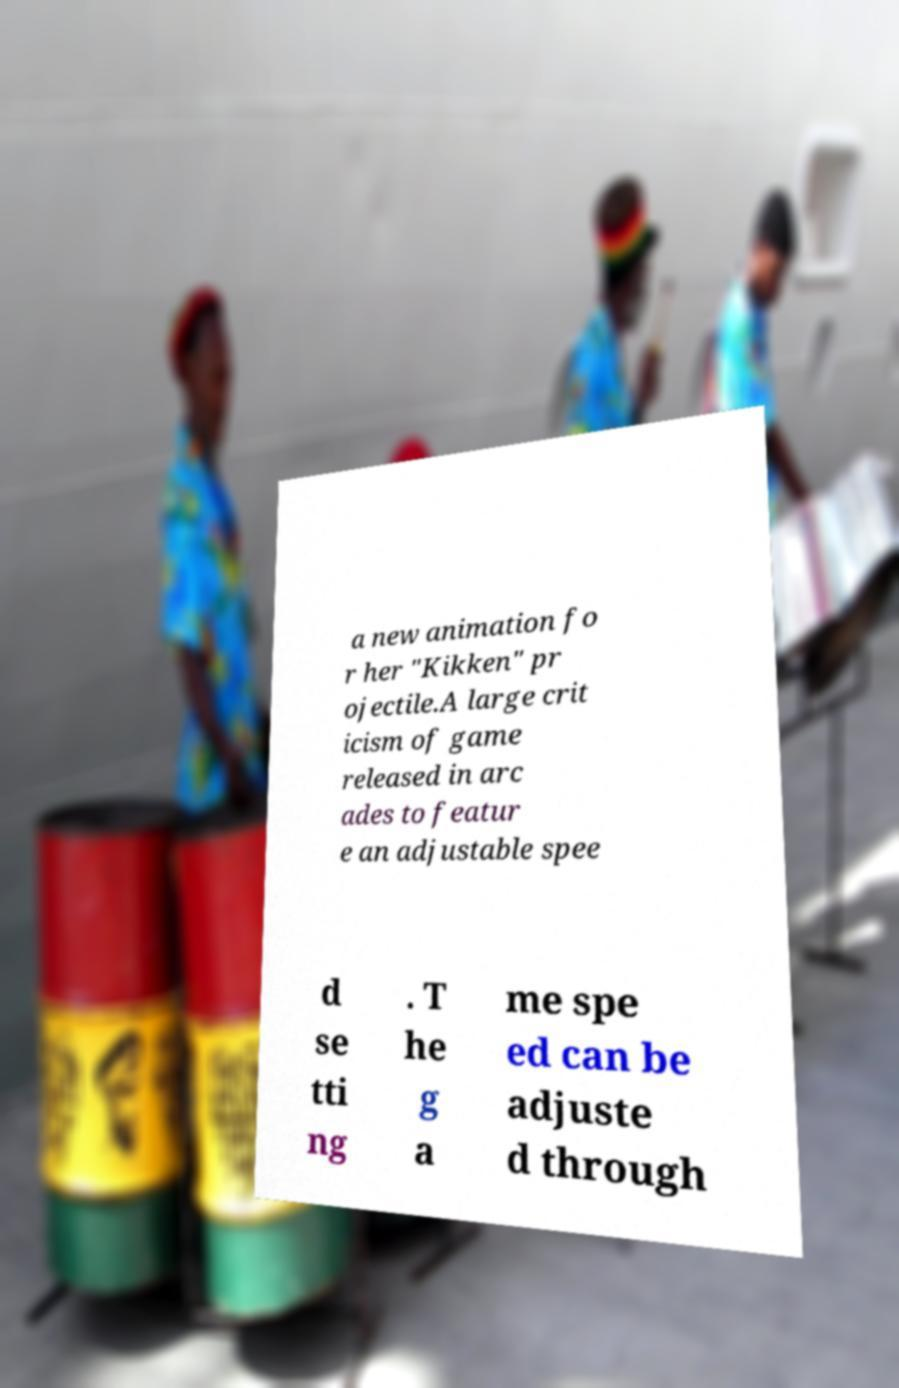For documentation purposes, I need the text within this image transcribed. Could you provide that? a new animation fo r her "Kikken" pr ojectile.A large crit icism of game released in arc ades to featur e an adjustable spee d se tti ng . T he g a me spe ed can be adjuste d through 